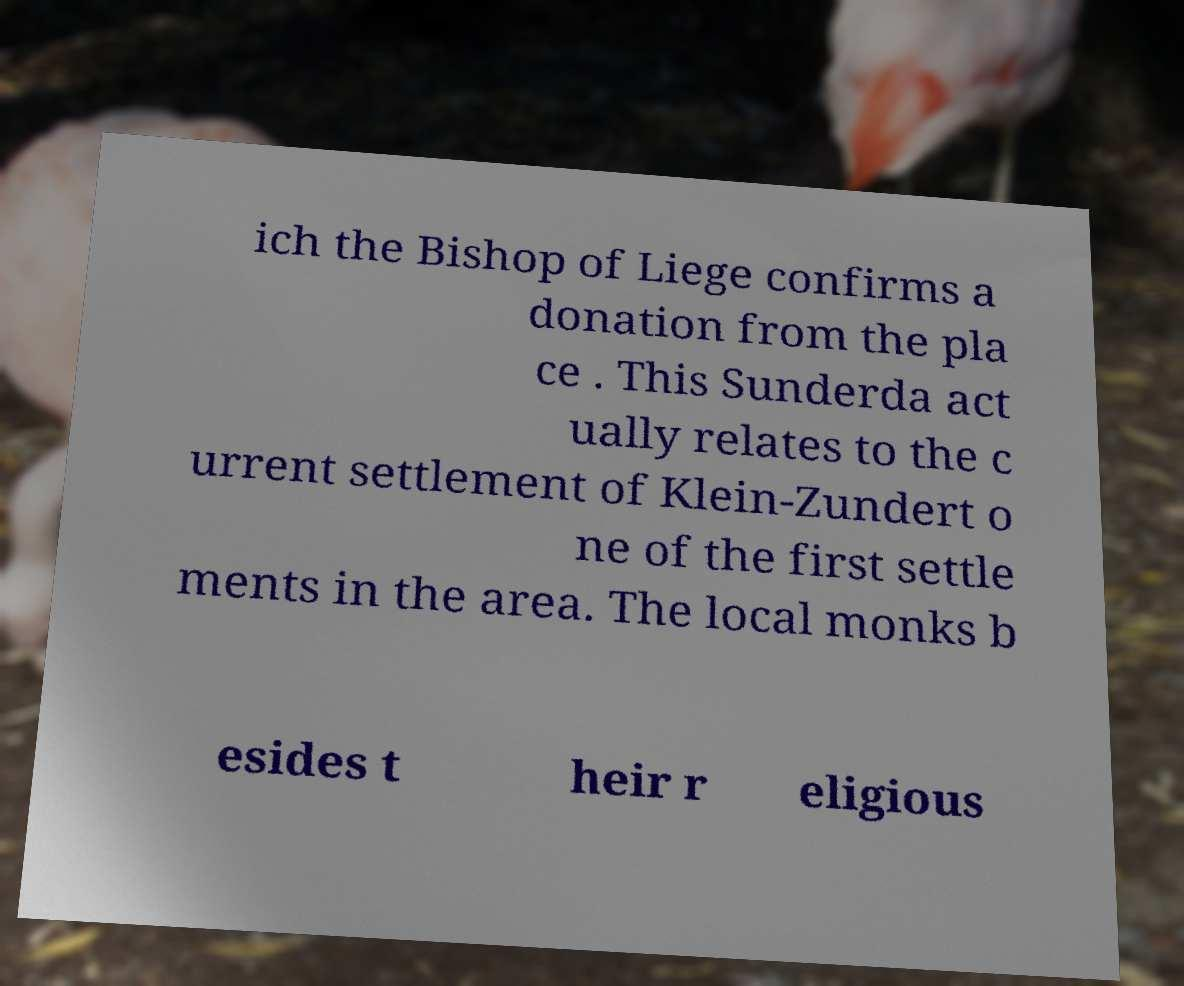For documentation purposes, I need the text within this image transcribed. Could you provide that? ich the Bishop of Liege confirms a donation from the pla ce . This Sunderda act ually relates to the c urrent settlement of Klein-Zundert o ne of the first settle ments in the area. The local monks b esides t heir r eligious 